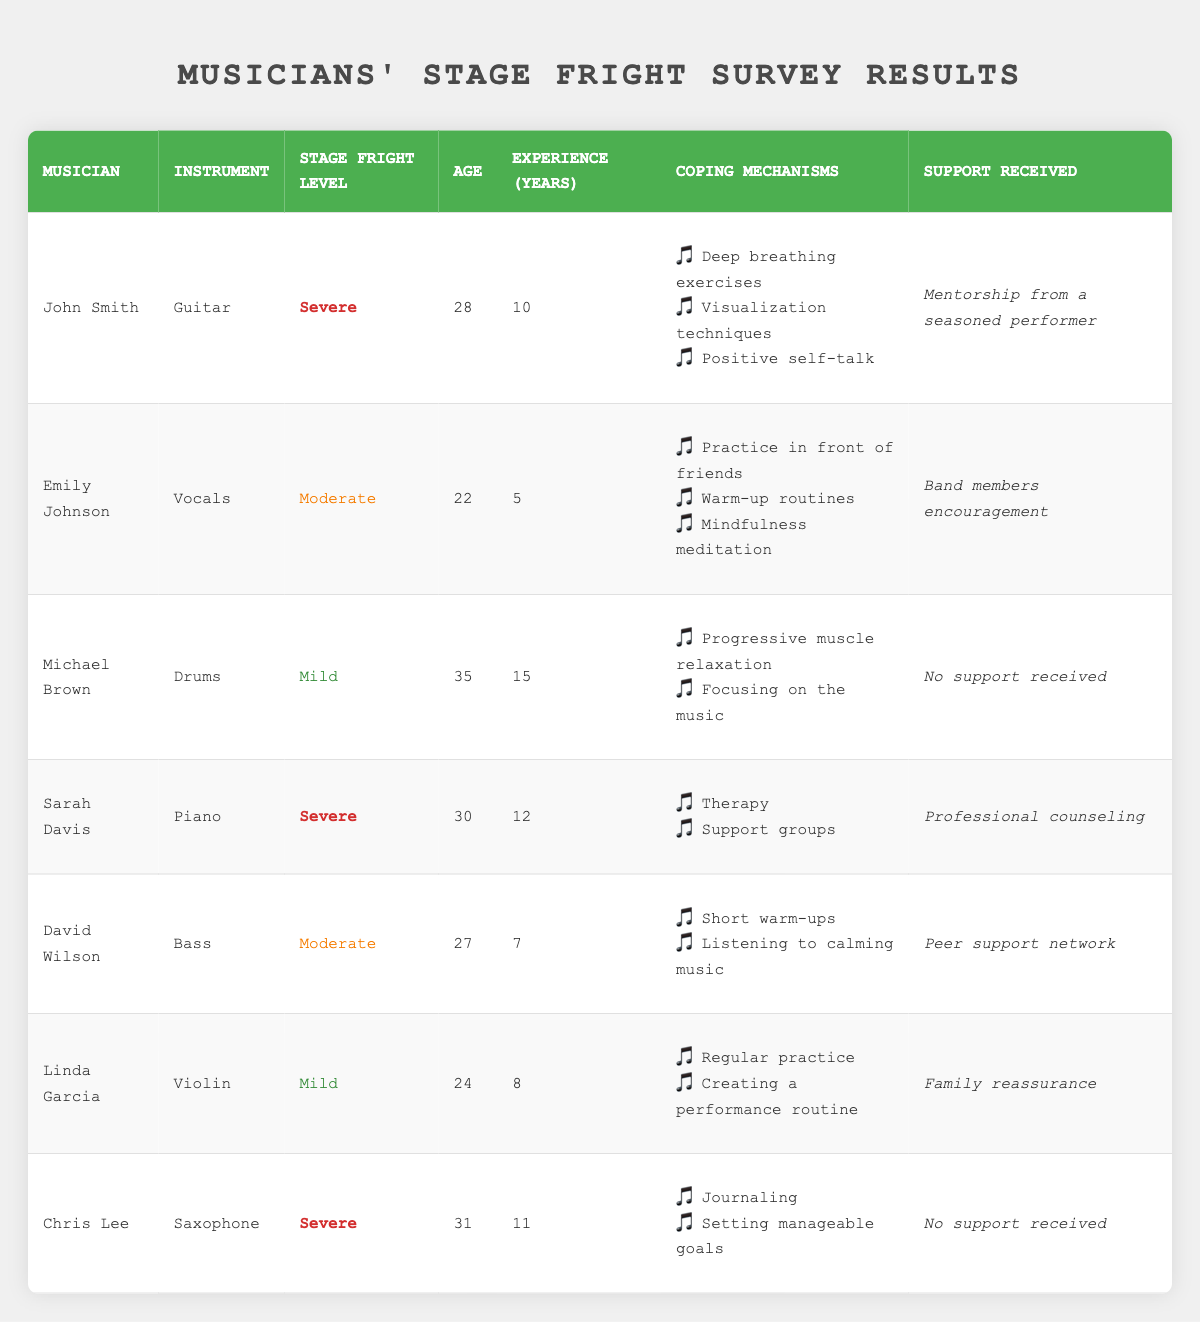What is the stage fright level of John Smith? The table lists John Smith's details. Under the "Stage Fright Level" column, it shows "Severe" for him.
Answer: Severe Which musician has the highest level of stage fright? By comparing the "Stage Fright Level" column for all musicians, John Smith, Sarah Davis, and Chris Lee all have "Severe" listed. Therefore, multiple musicians share the highest level.
Answer: John Smith, Sarah Davis, Chris Lee How old is the musician with the lowest stage fright level? The lowest stage fright level is "Mild." By checking the table, Michael Brown and Linda Garcia both have "Mild." Michael Brown is 35, while Linda Garcia is 24, making her the youngest among them.
Answer: 24 What coping mechanisms does Sarah Davis use? To find the coping mechanisms for Sarah Davis, I look at her entry in the table. It lists "Therapy" and "Support groups" as her coping mechanisms.
Answer: Therapy, Support groups Is David Wilson receiving any support for his stage fright? The "Support Received" column mentions whether David Wilson received support. His entry states "Peer support network," meaning he does.
Answer: Yes What is the average age of musicians who experience moderate stage fright? David Wilson and Emily Johnson are the musicians listed with "Moderate" stage fright. Their ages are 27 and 22, respectively. The average is calculated as (27 + 22) / 2 = 24.5.
Answer: 24.5 What percentage of musicians received support during their experiences with stage fright? Total musicians surveyed is 7. Count those who received support: John Smith, Emily Johnson, Sarah Davis, David Wilson, and Linda Garcia gives us 5 musicians. The percent is (5 / 7) * 100 = approximately 71.43%.
Answer: 71.43% Are any musicians without support experiencing severe stage fright? Checking the "Support Received" column, Chris Lee and Michael Brown are without support. Among them, Chris Lee has "Severe" stage fright while Michael Brown has "Mild." Thus, at least one musician without support is experiencing severe stage fright.
Answer: Yes How many years of performance experience does the oldest musician with mild stage fright have? The only musician with "Mild" stage fright is Michael Brown, who is 35 years old and has 15 years of performance experience.
Answer: 15 